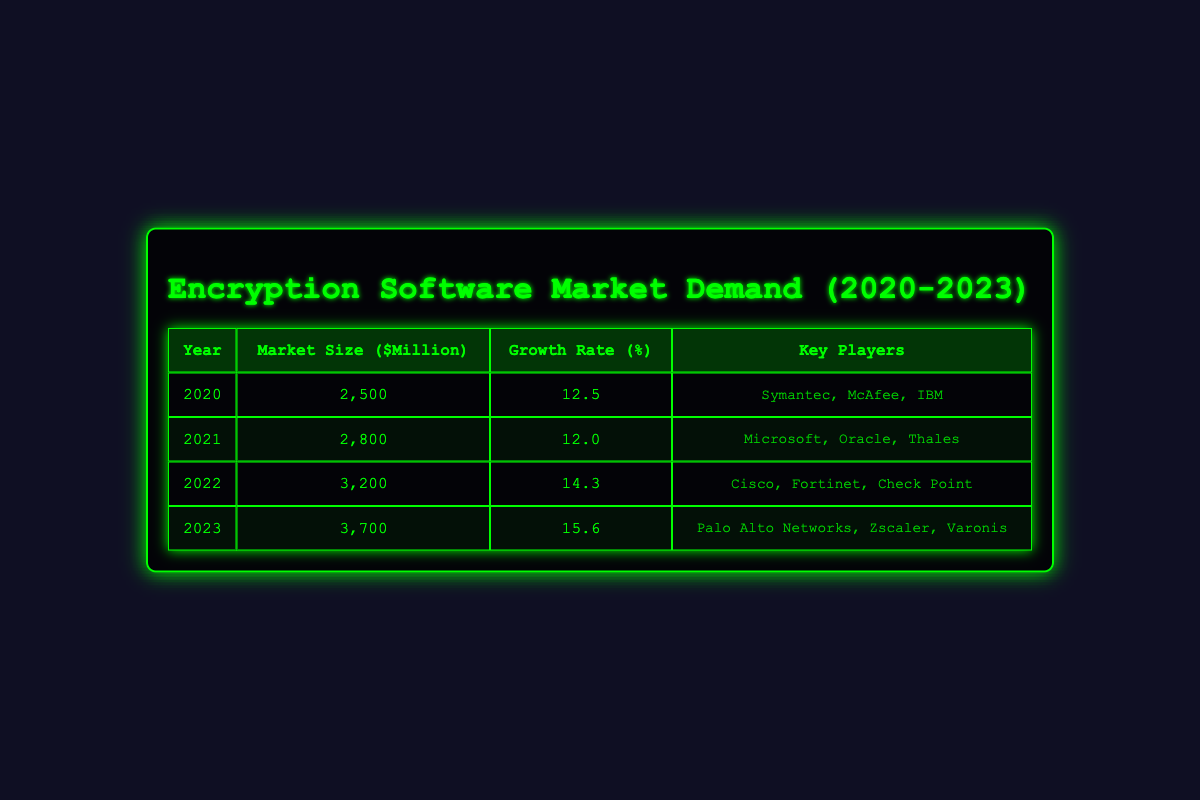What was the market size for encryption software in 2020? According to the table in the 2020 row, the market size for encryption software is listed as 2500 million dollars.
Answer: 2500 million dollars Which year had the highest growth rate in the encryption software market? By looking at the growth rates for each year, 2023 has the highest growth rate of 15.6 percent, which is higher than all the other years listed.
Answer: 2023 What is the total market size for encryption software from 2020 to 2023? To find the total market size, we add the market sizes from each year: 2500 + 2800 + 3200 + 3700 = 12200 million dollars.
Answer: 12200 million dollars Did Cisco feature as a key player in the encryption software market in 2021? In the table, Cisco is listed as a key player only in 2022. Therefore, it did not feature in 2021.
Answer: No What is the average market size for encryption software from 2020 to 2023? The market sizes over the four years are 2500, 2800, 3200, and 3700. First, we sum these values: 2500 + 2800 + 3200 + 3700 = 12200 million dollars. Then we divide by 4 (the number of years): 12200 / 4 = 3050 million dollars.
Answer: 3050 million dollars Which year experienced a greater market increase, 2021 or 2022? The market size in 2021 is 2800 million dollars and in 2022 it is 3200 million dollars. The difference is calculated by subtracting 2800 from 3200, resulting in an increase of 400 million dollars. Thus, 2022 experienced a greater increase compared to 2021.
Answer: 2022 How many key players are listed for the year 2023 and what are their names? In the 2023 row, three key players are listed: Palo Alto Networks, Zscaler, and Varonis, making a total of three key players for that year.
Answer: Three (Palo Alto Networks, Zscaler, Varonis) Is the average growth rate from 2020 to 2023 greater than 13 percent? To determine this, we add the growth rates for each year: 12.5 + 12.0 + 14.3 + 15.6 = 54.4 percent. Then we divide this total by 4 to find the average: 54.4 / 4 = 13.6 percent, which is greater than 13 percent.
Answer: Yes 